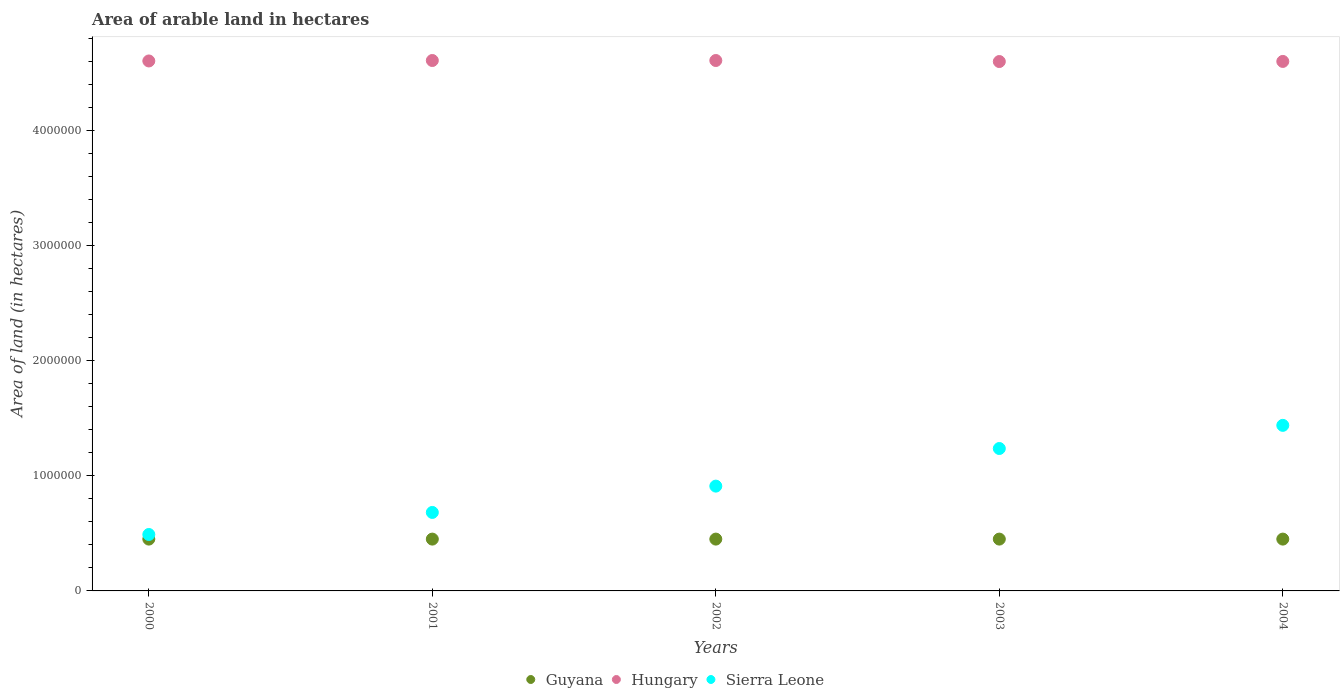How many different coloured dotlines are there?
Your answer should be very brief. 3. What is the total arable land in Sierra Leone in 2004?
Offer a terse response. 1.44e+06. Across all years, what is the maximum total arable land in Guyana?
Keep it short and to the point. 4.50e+05. Across all years, what is the minimum total arable land in Sierra Leone?
Make the answer very short. 4.90e+05. In which year was the total arable land in Hungary maximum?
Provide a succinct answer. 2001. What is the total total arable land in Sierra Leone in the graph?
Provide a succinct answer. 4.76e+06. What is the difference between the total arable land in Sierra Leone in 2001 and that in 2003?
Provide a succinct answer. -5.55e+05. What is the difference between the total arable land in Sierra Leone in 2004 and the total arable land in Guyana in 2003?
Ensure brevity in your answer.  9.88e+05. What is the average total arable land in Sierra Leone per year?
Keep it short and to the point. 9.51e+05. In the year 2002, what is the difference between the total arable land in Hungary and total arable land in Guyana?
Offer a very short reply. 4.16e+06. In how many years, is the total arable land in Hungary greater than 600000 hectares?
Offer a terse response. 5. What is the ratio of the total arable land in Sierra Leone in 2000 to that in 2001?
Keep it short and to the point. 0.72. Is the total arable land in Guyana in 2001 less than that in 2003?
Provide a short and direct response. No. Is the difference between the total arable land in Hungary in 2000 and 2002 greater than the difference between the total arable land in Guyana in 2000 and 2002?
Give a very brief answer. No. What is the difference between the highest and the lowest total arable land in Hungary?
Keep it short and to the point. 9000. Is the sum of the total arable land in Hungary in 2000 and 2002 greater than the maximum total arable land in Sierra Leone across all years?
Your answer should be compact. Yes. Is it the case that in every year, the sum of the total arable land in Guyana and total arable land in Hungary  is greater than the total arable land in Sierra Leone?
Ensure brevity in your answer.  Yes. Does the total arable land in Sierra Leone monotonically increase over the years?
Make the answer very short. Yes. Is the total arable land in Sierra Leone strictly greater than the total arable land in Hungary over the years?
Your answer should be compact. No. How many years are there in the graph?
Give a very brief answer. 5. What is the difference between two consecutive major ticks on the Y-axis?
Ensure brevity in your answer.  1.00e+06. Are the values on the major ticks of Y-axis written in scientific E-notation?
Your response must be concise. No. Does the graph contain grids?
Give a very brief answer. No. Where does the legend appear in the graph?
Provide a short and direct response. Bottom center. How many legend labels are there?
Ensure brevity in your answer.  3. What is the title of the graph?
Offer a terse response. Area of arable land in hectares. Does "Trinidad and Tobago" appear as one of the legend labels in the graph?
Your answer should be compact. No. What is the label or title of the X-axis?
Your answer should be very brief. Years. What is the label or title of the Y-axis?
Offer a very short reply. Area of land (in hectares). What is the Area of land (in hectares) of Guyana in 2000?
Ensure brevity in your answer.  4.50e+05. What is the Area of land (in hectares) of Hungary in 2000?
Provide a short and direct response. 4.60e+06. What is the Area of land (in hectares) of Guyana in 2001?
Keep it short and to the point. 4.50e+05. What is the Area of land (in hectares) of Hungary in 2001?
Provide a short and direct response. 4.61e+06. What is the Area of land (in hectares) of Sierra Leone in 2001?
Give a very brief answer. 6.82e+05. What is the Area of land (in hectares) in Hungary in 2002?
Keep it short and to the point. 4.61e+06. What is the Area of land (in hectares) of Sierra Leone in 2002?
Your response must be concise. 9.10e+05. What is the Area of land (in hectares) of Guyana in 2003?
Your answer should be compact. 4.50e+05. What is the Area of land (in hectares) in Hungary in 2003?
Provide a succinct answer. 4.60e+06. What is the Area of land (in hectares) in Sierra Leone in 2003?
Your answer should be very brief. 1.24e+06. What is the Area of land (in hectares) of Hungary in 2004?
Offer a very short reply. 4.60e+06. What is the Area of land (in hectares) of Sierra Leone in 2004?
Offer a very short reply. 1.44e+06. Across all years, what is the maximum Area of land (in hectares) in Guyana?
Keep it short and to the point. 4.50e+05. Across all years, what is the maximum Area of land (in hectares) of Hungary?
Offer a very short reply. 4.61e+06. Across all years, what is the maximum Area of land (in hectares) in Sierra Leone?
Give a very brief answer. 1.44e+06. Across all years, what is the minimum Area of land (in hectares) in Hungary?
Your response must be concise. 4.60e+06. Across all years, what is the minimum Area of land (in hectares) of Sierra Leone?
Keep it short and to the point. 4.90e+05. What is the total Area of land (in hectares) of Guyana in the graph?
Offer a very short reply. 2.25e+06. What is the total Area of land (in hectares) in Hungary in the graph?
Offer a very short reply. 2.30e+07. What is the total Area of land (in hectares) in Sierra Leone in the graph?
Make the answer very short. 4.76e+06. What is the difference between the Area of land (in hectares) of Hungary in 2000 and that in 2001?
Ensure brevity in your answer.  -4000. What is the difference between the Area of land (in hectares) in Sierra Leone in 2000 and that in 2001?
Offer a very short reply. -1.92e+05. What is the difference between the Area of land (in hectares) in Hungary in 2000 and that in 2002?
Provide a short and direct response. -4000. What is the difference between the Area of land (in hectares) in Sierra Leone in 2000 and that in 2002?
Your answer should be very brief. -4.20e+05. What is the difference between the Area of land (in hectares) in Sierra Leone in 2000 and that in 2003?
Offer a terse response. -7.47e+05. What is the difference between the Area of land (in hectares) in Hungary in 2000 and that in 2004?
Offer a very short reply. 4000. What is the difference between the Area of land (in hectares) in Sierra Leone in 2000 and that in 2004?
Your answer should be very brief. -9.48e+05. What is the difference between the Area of land (in hectares) of Guyana in 2001 and that in 2002?
Ensure brevity in your answer.  0. What is the difference between the Area of land (in hectares) in Hungary in 2001 and that in 2002?
Make the answer very short. 0. What is the difference between the Area of land (in hectares) of Sierra Leone in 2001 and that in 2002?
Your answer should be very brief. -2.29e+05. What is the difference between the Area of land (in hectares) in Hungary in 2001 and that in 2003?
Offer a very short reply. 9000. What is the difference between the Area of land (in hectares) in Sierra Leone in 2001 and that in 2003?
Provide a succinct answer. -5.55e+05. What is the difference between the Area of land (in hectares) in Hungary in 2001 and that in 2004?
Ensure brevity in your answer.  8000. What is the difference between the Area of land (in hectares) in Sierra Leone in 2001 and that in 2004?
Ensure brevity in your answer.  -7.56e+05. What is the difference between the Area of land (in hectares) of Guyana in 2002 and that in 2003?
Your response must be concise. 0. What is the difference between the Area of land (in hectares) of Hungary in 2002 and that in 2003?
Your answer should be compact. 9000. What is the difference between the Area of land (in hectares) of Sierra Leone in 2002 and that in 2003?
Ensure brevity in your answer.  -3.27e+05. What is the difference between the Area of land (in hectares) of Guyana in 2002 and that in 2004?
Offer a terse response. 0. What is the difference between the Area of land (in hectares) of Hungary in 2002 and that in 2004?
Make the answer very short. 8000. What is the difference between the Area of land (in hectares) in Sierra Leone in 2002 and that in 2004?
Keep it short and to the point. -5.28e+05. What is the difference between the Area of land (in hectares) in Guyana in 2003 and that in 2004?
Offer a terse response. 0. What is the difference between the Area of land (in hectares) of Hungary in 2003 and that in 2004?
Provide a short and direct response. -1000. What is the difference between the Area of land (in hectares) of Sierra Leone in 2003 and that in 2004?
Provide a short and direct response. -2.01e+05. What is the difference between the Area of land (in hectares) in Guyana in 2000 and the Area of land (in hectares) in Hungary in 2001?
Make the answer very short. -4.16e+06. What is the difference between the Area of land (in hectares) in Guyana in 2000 and the Area of land (in hectares) in Sierra Leone in 2001?
Offer a very short reply. -2.32e+05. What is the difference between the Area of land (in hectares) in Hungary in 2000 and the Area of land (in hectares) in Sierra Leone in 2001?
Provide a succinct answer. 3.92e+06. What is the difference between the Area of land (in hectares) of Guyana in 2000 and the Area of land (in hectares) of Hungary in 2002?
Provide a succinct answer. -4.16e+06. What is the difference between the Area of land (in hectares) in Guyana in 2000 and the Area of land (in hectares) in Sierra Leone in 2002?
Offer a terse response. -4.60e+05. What is the difference between the Area of land (in hectares) of Hungary in 2000 and the Area of land (in hectares) of Sierra Leone in 2002?
Your answer should be very brief. 3.69e+06. What is the difference between the Area of land (in hectares) of Guyana in 2000 and the Area of land (in hectares) of Hungary in 2003?
Your answer should be very brief. -4.15e+06. What is the difference between the Area of land (in hectares) in Guyana in 2000 and the Area of land (in hectares) in Sierra Leone in 2003?
Your answer should be very brief. -7.87e+05. What is the difference between the Area of land (in hectares) of Hungary in 2000 and the Area of land (in hectares) of Sierra Leone in 2003?
Offer a very short reply. 3.37e+06. What is the difference between the Area of land (in hectares) of Guyana in 2000 and the Area of land (in hectares) of Hungary in 2004?
Provide a succinct answer. -4.15e+06. What is the difference between the Area of land (in hectares) of Guyana in 2000 and the Area of land (in hectares) of Sierra Leone in 2004?
Make the answer very short. -9.88e+05. What is the difference between the Area of land (in hectares) of Hungary in 2000 and the Area of land (in hectares) of Sierra Leone in 2004?
Your response must be concise. 3.16e+06. What is the difference between the Area of land (in hectares) in Guyana in 2001 and the Area of land (in hectares) in Hungary in 2002?
Provide a short and direct response. -4.16e+06. What is the difference between the Area of land (in hectares) of Guyana in 2001 and the Area of land (in hectares) of Sierra Leone in 2002?
Offer a terse response. -4.60e+05. What is the difference between the Area of land (in hectares) in Hungary in 2001 and the Area of land (in hectares) in Sierra Leone in 2002?
Offer a terse response. 3.70e+06. What is the difference between the Area of land (in hectares) of Guyana in 2001 and the Area of land (in hectares) of Hungary in 2003?
Offer a terse response. -4.15e+06. What is the difference between the Area of land (in hectares) of Guyana in 2001 and the Area of land (in hectares) of Sierra Leone in 2003?
Ensure brevity in your answer.  -7.87e+05. What is the difference between the Area of land (in hectares) in Hungary in 2001 and the Area of land (in hectares) in Sierra Leone in 2003?
Make the answer very short. 3.37e+06. What is the difference between the Area of land (in hectares) in Guyana in 2001 and the Area of land (in hectares) in Hungary in 2004?
Provide a succinct answer. -4.15e+06. What is the difference between the Area of land (in hectares) in Guyana in 2001 and the Area of land (in hectares) in Sierra Leone in 2004?
Your answer should be very brief. -9.88e+05. What is the difference between the Area of land (in hectares) in Hungary in 2001 and the Area of land (in hectares) in Sierra Leone in 2004?
Keep it short and to the point. 3.17e+06. What is the difference between the Area of land (in hectares) in Guyana in 2002 and the Area of land (in hectares) in Hungary in 2003?
Keep it short and to the point. -4.15e+06. What is the difference between the Area of land (in hectares) of Guyana in 2002 and the Area of land (in hectares) of Sierra Leone in 2003?
Keep it short and to the point. -7.87e+05. What is the difference between the Area of land (in hectares) in Hungary in 2002 and the Area of land (in hectares) in Sierra Leone in 2003?
Give a very brief answer. 3.37e+06. What is the difference between the Area of land (in hectares) of Guyana in 2002 and the Area of land (in hectares) of Hungary in 2004?
Give a very brief answer. -4.15e+06. What is the difference between the Area of land (in hectares) of Guyana in 2002 and the Area of land (in hectares) of Sierra Leone in 2004?
Your response must be concise. -9.88e+05. What is the difference between the Area of land (in hectares) in Hungary in 2002 and the Area of land (in hectares) in Sierra Leone in 2004?
Give a very brief answer. 3.17e+06. What is the difference between the Area of land (in hectares) of Guyana in 2003 and the Area of land (in hectares) of Hungary in 2004?
Your response must be concise. -4.15e+06. What is the difference between the Area of land (in hectares) of Guyana in 2003 and the Area of land (in hectares) of Sierra Leone in 2004?
Your answer should be very brief. -9.88e+05. What is the difference between the Area of land (in hectares) of Hungary in 2003 and the Area of land (in hectares) of Sierra Leone in 2004?
Make the answer very short. 3.16e+06. What is the average Area of land (in hectares) in Hungary per year?
Make the answer very short. 4.60e+06. What is the average Area of land (in hectares) of Sierra Leone per year?
Your answer should be very brief. 9.51e+05. In the year 2000, what is the difference between the Area of land (in hectares) in Guyana and Area of land (in hectares) in Hungary?
Your response must be concise. -4.15e+06. In the year 2000, what is the difference between the Area of land (in hectares) of Guyana and Area of land (in hectares) of Sierra Leone?
Provide a short and direct response. -4.00e+04. In the year 2000, what is the difference between the Area of land (in hectares) in Hungary and Area of land (in hectares) in Sierra Leone?
Provide a succinct answer. 4.11e+06. In the year 2001, what is the difference between the Area of land (in hectares) in Guyana and Area of land (in hectares) in Hungary?
Your answer should be compact. -4.16e+06. In the year 2001, what is the difference between the Area of land (in hectares) of Guyana and Area of land (in hectares) of Sierra Leone?
Make the answer very short. -2.32e+05. In the year 2001, what is the difference between the Area of land (in hectares) in Hungary and Area of land (in hectares) in Sierra Leone?
Offer a terse response. 3.92e+06. In the year 2002, what is the difference between the Area of land (in hectares) in Guyana and Area of land (in hectares) in Hungary?
Provide a short and direct response. -4.16e+06. In the year 2002, what is the difference between the Area of land (in hectares) in Guyana and Area of land (in hectares) in Sierra Leone?
Keep it short and to the point. -4.60e+05. In the year 2002, what is the difference between the Area of land (in hectares) of Hungary and Area of land (in hectares) of Sierra Leone?
Provide a short and direct response. 3.70e+06. In the year 2003, what is the difference between the Area of land (in hectares) in Guyana and Area of land (in hectares) in Hungary?
Make the answer very short. -4.15e+06. In the year 2003, what is the difference between the Area of land (in hectares) in Guyana and Area of land (in hectares) in Sierra Leone?
Your answer should be very brief. -7.87e+05. In the year 2003, what is the difference between the Area of land (in hectares) in Hungary and Area of land (in hectares) in Sierra Leone?
Offer a very short reply. 3.36e+06. In the year 2004, what is the difference between the Area of land (in hectares) in Guyana and Area of land (in hectares) in Hungary?
Your response must be concise. -4.15e+06. In the year 2004, what is the difference between the Area of land (in hectares) of Guyana and Area of land (in hectares) of Sierra Leone?
Offer a very short reply. -9.88e+05. In the year 2004, what is the difference between the Area of land (in hectares) of Hungary and Area of land (in hectares) of Sierra Leone?
Your response must be concise. 3.16e+06. What is the ratio of the Area of land (in hectares) of Sierra Leone in 2000 to that in 2001?
Your answer should be very brief. 0.72. What is the ratio of the Area of land (in hectares) of Hungary in 2000 to that in 2002?
Provide a succinct answer. 1. What is the ratio of the Area of land (in hectares) in Sierra Leone in 2000 to that in 2002?
Offer a very short reply. 0.54. What is the ratio of the Area of land (in hectares) of Sierra Leone in 2000 to that in 2003?
Offer a very short reply. 0.4. What is the ratio of the Area of land (in hectares) in Guyana in 2000 to that in 2004?
Make the answer very short. 1. What is the ratio of the Area of land (in hectares) of Hungary in 2000 to that in 2004?
Give a very brief answer. 1. What is the ratio of the Area of land (in hectares) in Sierra Leone in 2000 to that in 2004?
Provide a short and direct response. 0.34. What is the ratio of the Area of land (in hectares) of Hungary in 2001 to that in 2002?
Your answer should be compact. 1. What is the ratio of the Area of land (in hectares) of Sierra Leone in 2001 to that in 2002?
Your response must be concise. 0.75. What is the ratio of the Area of land (in hectares) of Guyana in 2001 to that in 2003?
Provide a short and direct response. 1. What is the ratio of the Area of land (in hectares) in Sierra Leone in 2001 to that in 2003?
Give a very brief answer. 0.55. What is the ratio of the Area of land (in hectares) of Guyana in 2001 to that in 2004?
Make the answer very short. 1. What is the ratio of the Area of land (in hectares) of Hungary in 2001 to that in 2004?
Keep it short and to the point. 1. What is the ratio of the Area of land (in hectares) of Sierra Leone in 2001 to that in 2004?
Your response must be concise. 0.47. What is the ratio of the Area of land (in hectares) of Hungary in 2002 to that in 2003?
Keep it short and to the point. 1. What is the ratio of the Area of land (in hectares) of Sierra Leone in 2002 to that in 2003?
Your response must be concise. 0.74. What is the ratio of the Area of land (in hectares) in Guyana in 2002 to that in 2004?
Your response must be concise. 1. What is the ratio of the Area of land (in hectares) in Sierra Leone in 2002 to that in 2004?
Make the answer very short. 0.63. What is the ratio of the Area of land (in hectares) in Hungary in 2003 to that in 2004?
Make the answer very short. 1. What is the ratio of the Area of land (in hectares) of Sierra Leone in 2003 to that in 2004?
Your answer should be very brief. 0.86. What is the difference between the highest and the second highest Area of land (in hectares) of Sierra Leone?
Provide a short and direct response. 2.01e+05. What is the difference between the highest and the lowest Area of land (in hectares) of Guyana?
Offer a very short reply. 0. What is the difference between the highest and the lowest Area of land (in hectares) of Hungary?
Provide a short and direct response. 9000. What is the difference between the highest and the lowest Area of land (in hectares) in Sierra Leone?
Provide a short and direct response. 9.48e+05. 